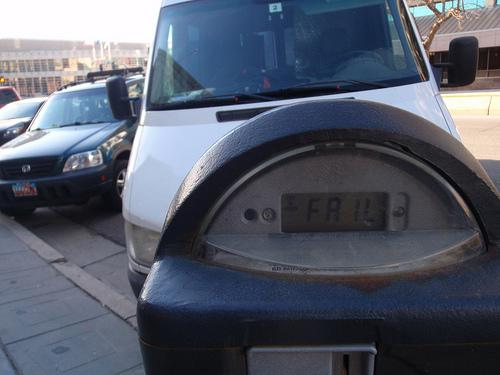Question: where is this scene?
Choices:
A. At a parking garage.
B. At a parking lot.
C. At a driveway.
D. At a parking meter.
Answer with the letter. Answer: D Question: how is the car?
Choices:
A. Old.
B. Smelly.
C. Parked.
D. Brand new.
Answer with the letter. Answer: C Question: what is this?
Choices:
A. Bus.
B. Motorcycle.
C. Car.
D. Plane.
Answer with the letter. Answer: C Question: who is present?
Choices:
A. 1 person.
B. 2 people.
C. Nobody.
D. 3 people.
Answer with the letter. Answer: C 